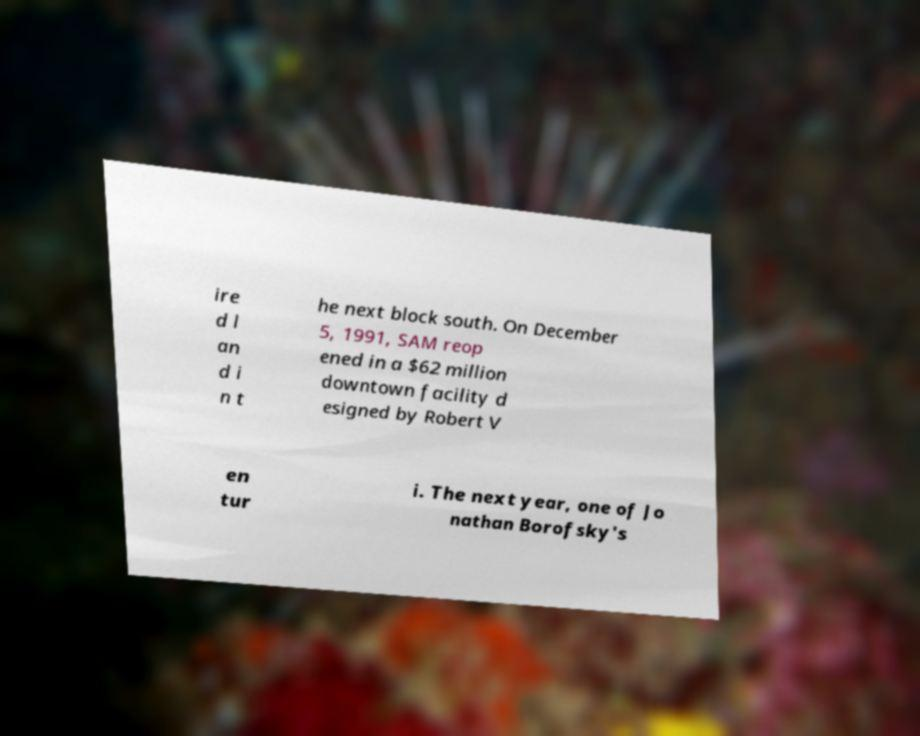I need the written content from this picture converted into text. Can you do that? ire d l an d i n t he next block south. On December 5, 1991, SAM reop ened in a $62 million downtown facility d esigned by Robert V en tur i. The next year, one of Jo nathan Borofsky's 